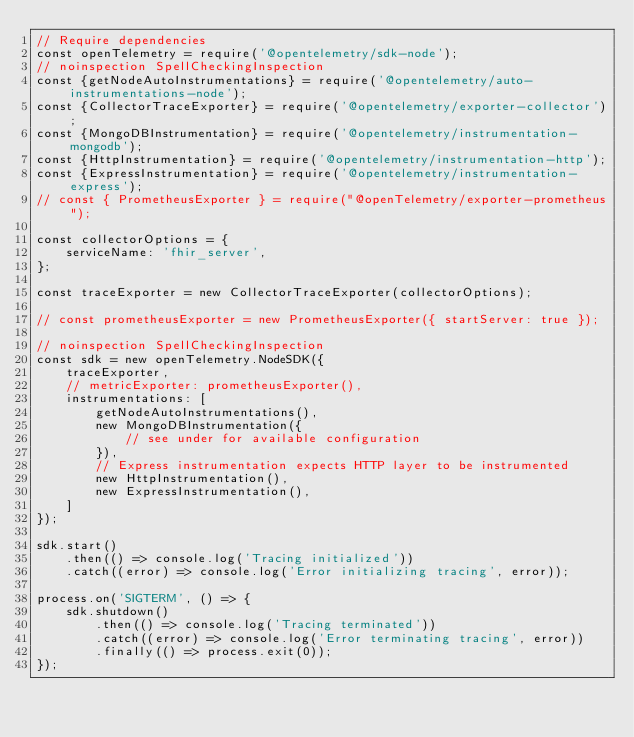<code> <loc_0><loc_0><loc_500><loc_500><_JavaScript_>// Require dependencies
const openTelemetry = require('@opentelemetry/sdk-node');
// noinspection SpellCheckingInspection
const {getNodeAutoInstrumentations} = require('@opentelemetry/auto-instrumentations-node');
const {CollectorTraceExporter} = require('@opentelemetry/exporter-collector');
const {MongoDBInstrumentation} = require('@opentelemetry/instrumentation-mongodb');
const {HttpInstrumentation} = require('@opentelemetry/instrumentation-http');
const {ExpressInstrumentation} = require('@opentelemetry/instrumentation-express');
// const { PrometheusExporter } = require("@openTelemetry/exporter-prometheus");

const collectorOptions = {
    serviceName: 'fhir_server',
};

const traceExporter = new CollectorTraceExporter(collectorOptions);

// const prometheusExporter = new PrometheusExporter({ startServer: true });

// noinspection SpellCheckingInspection
const sdk = new openTelemetry.NodeSDK({
    traceExporter,
    // metricExporter: prometheusExporter(),
    instrumentations: [
        getNodeAutoInstrumentations(),
        new MongoDBInstrumentation({
            // see under for available configuration
        }),
        // Express instrumentation expects HTTP layer to be instrumented
        new HttpInstrumentation(),
        new ExpressInstrumentation(),
    ]
});

sdk.start()
    .then(() => console.log('Tracing initialized'))
    .catch((error) => console.log('Error initializing tracing', error));

process.on('SIGTERM', () => {
    sdk.shutdown()
        .then(() => console.log('Tracing terminated'))
        .catch((error) => console.log('Error terminating tracing', error))
        .finally(() => process.exit(0));
});
</code> 